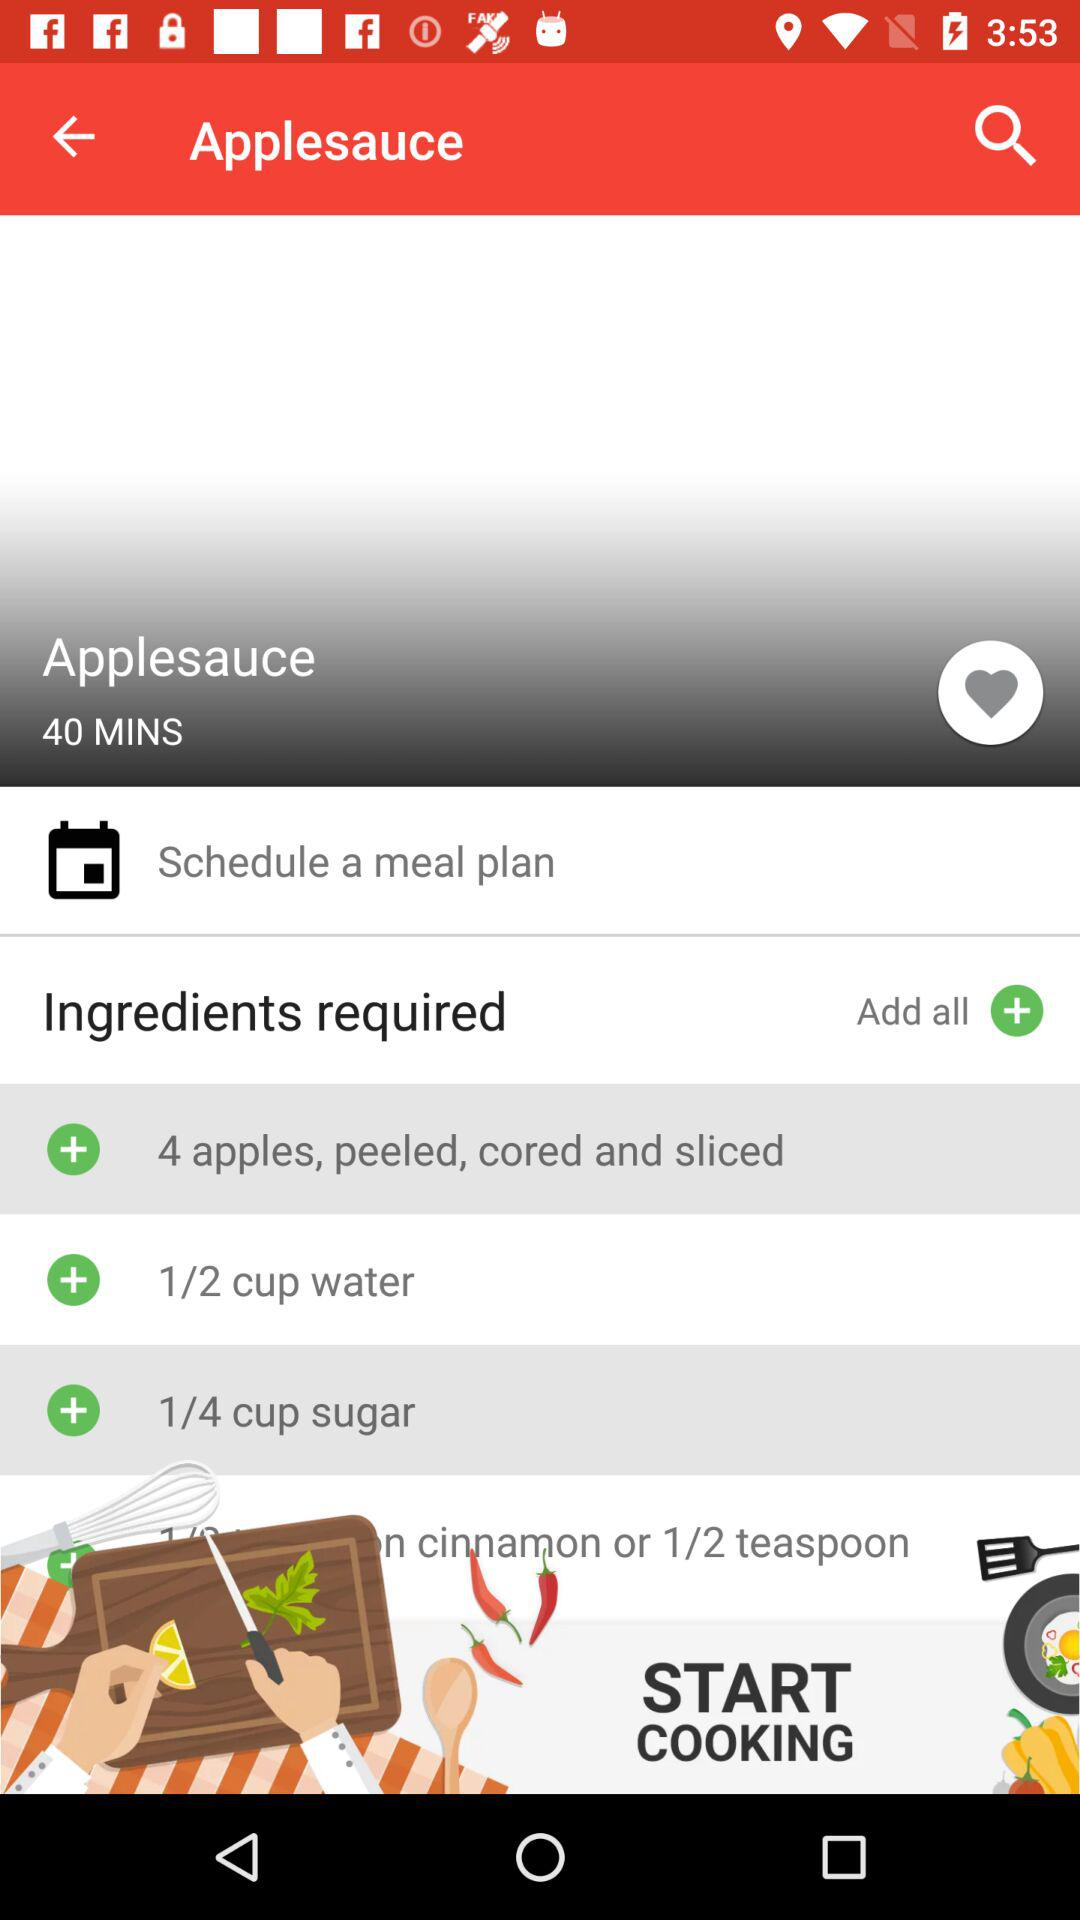What is the dish name? The name of the dish is applesauce. 